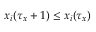<formula> <loc_0><loc_0><loc_500><loc_500>x _ { i } ( \tau _ { x } + 1 ) \leq x _ { i } ( \tau _ { x } )</formula> 